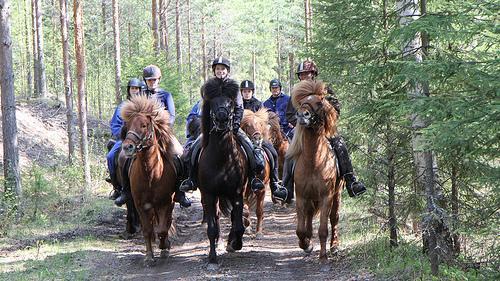How many people are in the scene?
Give a very brief answer. 6. 